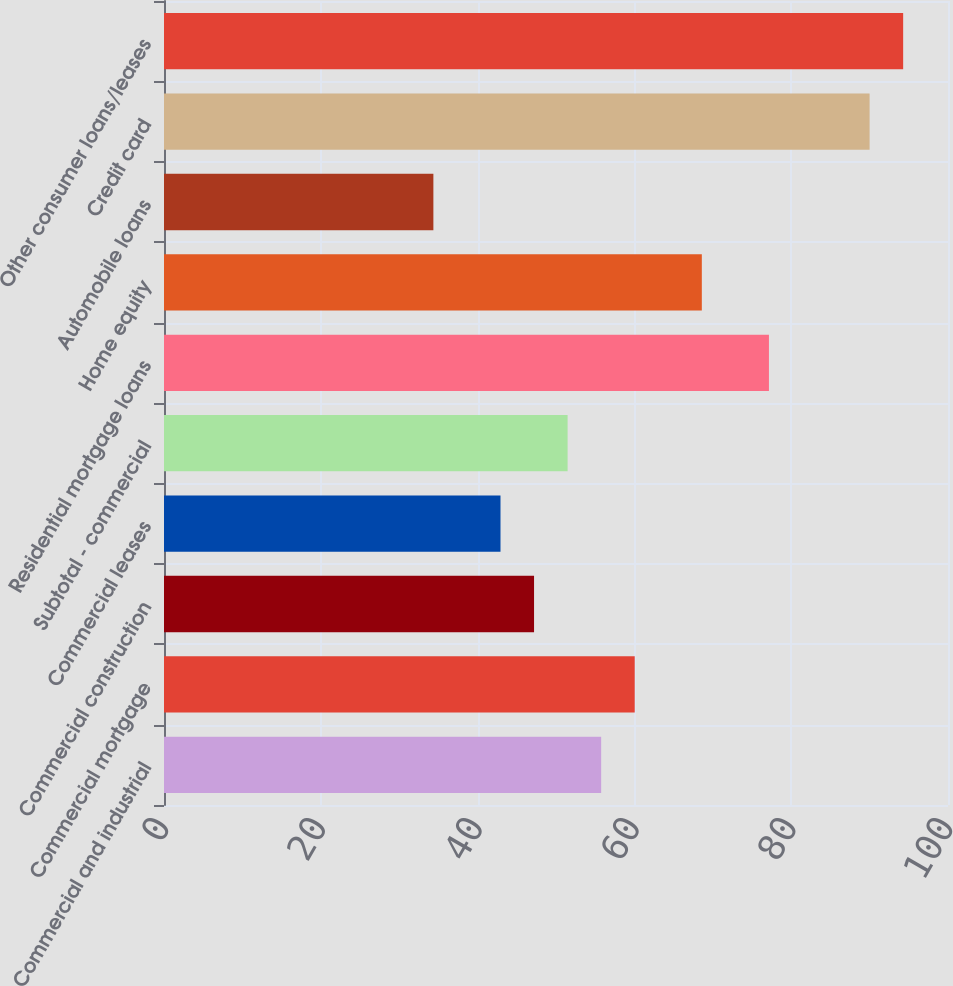Convert chart. <chart><loc_0><loc_0><loc_500><loc_500><bar_chart><fcel>Commercial and industrial<fcel>Commercial mortgage<fcel>Commercial construction<fcel>Commercial leases<fcel>Subtotal - commercial<fcel>Residential mortgage loans<fcel>Home equity<fcel>Automobile loans<fcel>Credit card<fcel>Other consumer loans/leases<nl><fcel>55.76<fcel>60.04<fcel>47.2<fcel>42.92<fcel>51.48<fcel>77.16<fcel>68.6<fcel>34.36<fcel>90<fcel>94.28<nl></chart> 